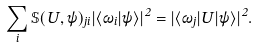Convert formula to latex. <formula><loc_0><loc_0><loc_500><loc_500>\sum _ { i } \mathbb { S } ( U , \psi ) _ { j i } | \langle \omega _ { i } | \psi \rangle | ^ { 2 } = | \langle \omega _ { j } | U | \psi \rangle | ^ { 2 } .</formula> 